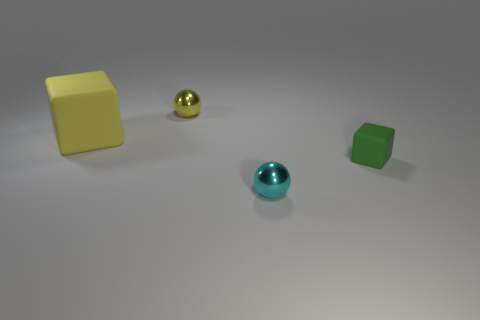Is there anything else that has the same size as the yellow cube?
Your answer should be very brief. No. There is a tiny thing that is the same material as the small yellow sphere; what color is it?
Give a very brief answer. Cyan. Are there fewer tiny yellow balls behind the small cube than big yellow rubber blocks that are behind the small yellow shiny sphere?
Your answer should be very brief. No. How many balls are the same color as the large cube?
Make the answer very short. 1. There is a small object that is the same color as the large rubber cube; what is its material?
Give a very brief answer. Metal. What number of balls are both in front of the yellow metallic object and left of the cyan metal sphere?
Ensure brevity in your answer.  0. There is a object in front of the rubber block in front of the yellow matte thing; what is it made of?
Keep it short and to the point. Metal. Are there any other cyan objects that have the same material as the tiny cyan thing?
Offer a terse response. No. There is a green block that is the same size as the yellow metallic ball; what is it made of?
Ensure brevity in your answer.  Rubber. What is the size of the metallic thing that is on the left side of the cyan shiny object to the right of the ball that is behind the small cube?
Offer a very short reply. Small. 